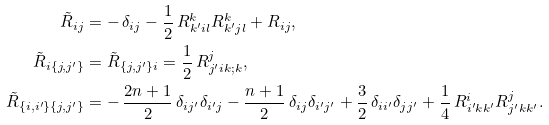Convert formula to latex. <formula><loc_0><loc_0><loc_500><loc_500>\tilde { R } _ { i j } & = - \, \delta _ { i j } - \frac { 1 } { 2 } \, R ^ { k } _ { k ^ { \prime } i l } R ^ { k } _ { k ^ { \prime } j l } + R _ { i j } , \\ \tilde { R } _ { i \{ j , j ^ { \prime } \} } & = \tilde { R } _ { \{ j , j ^ { \prime } \} i } = \frac { 1 } { 2 } \, R ^ { j } _ { j ^ { \prime } i k ; k } , \\ \tilde { R } _ { \{ i , i ^ { \prime } \} \{ j , j ^ { \prime } \} } & = - \, \frac { 2 n + 1 } 2 \, \delta _ { i j ^ { \prime } } \delta _ { i ^ { \prime } j } - \frac { n + 1 } 2 \, \delta _ { i j } \delta _ { i ^ { \prime } j ^ { \prime } } + \frac { 3 } { 2 } \, \delta _ { i i ^ { \prime } } \delta _ { j j ^ { \prime } } + \frac { 1 } { 4 } \, R ^ { i } _ { i ^ { \prime } k k ^ { \prime } } R ^ { j } _ { j ^ { \prime } k k ^ { \prime } } .</formula> 